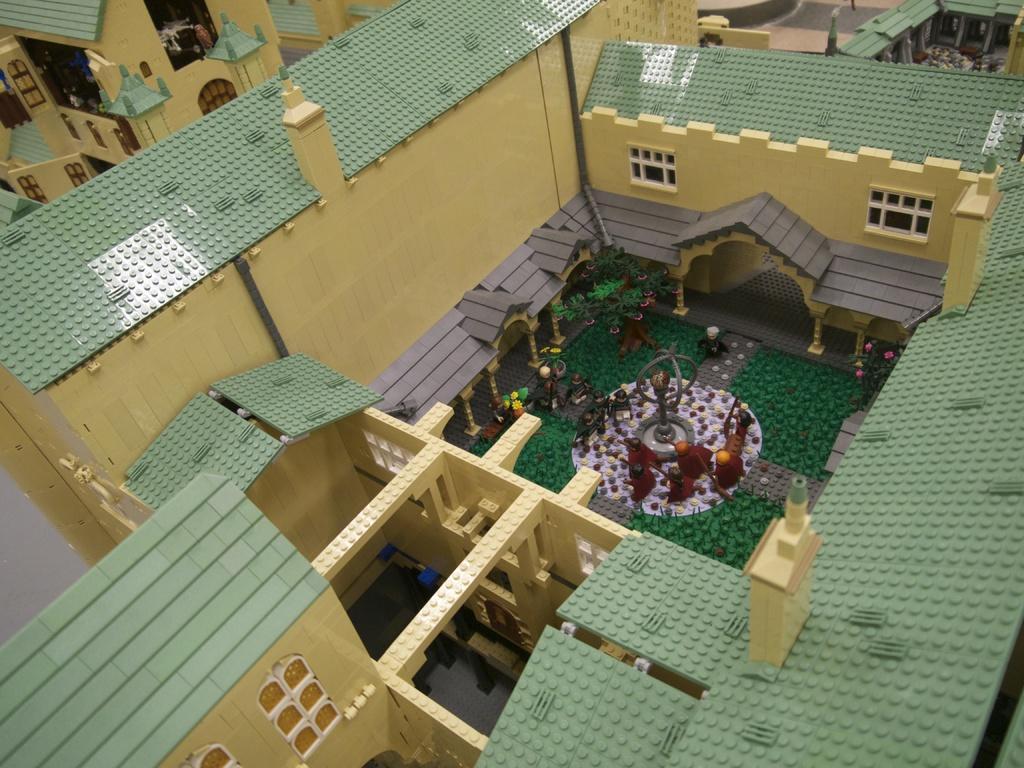Can you describe this image briefly? In the image we can see there is a building which is made up of blocks. 